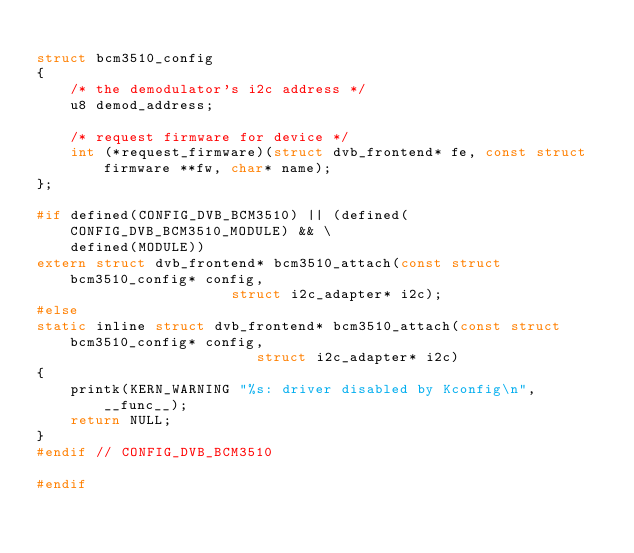Convert code to text. <code><loc_0><loc_0><loc_500><loc_500><_C_>
struct bcm3510_config
{
	/* the demodulator's i2c address */
	u8 demod_address;

	/* request firmware for device */
	int (*request_firmware)(struct dvb_frontend* fe, const struct firmware **fw, char* name);
};

#if defined(CONFIG_DVB_BCM3510) || (defined(CONFIG_DVB_BCM3510_MODULE) && \
	defined(MODULE))
extern struct dvb_frontend* bcm3510_attach(const struct bcm3510_config* config,
					   struct i2c_adapter* i2c);
#else
static inline struct dvb_frontend* bcm3510_attach(const struct bcm3510_config* config,
						  struct i2c_adapter* i2c)
{
	printk(KERN_WARNING "%s: driver disabled by Kconfig\n", __func__);
	return NULL;
}
#endif // CONFIG_DVB_BCM3510

#endif
</code> 